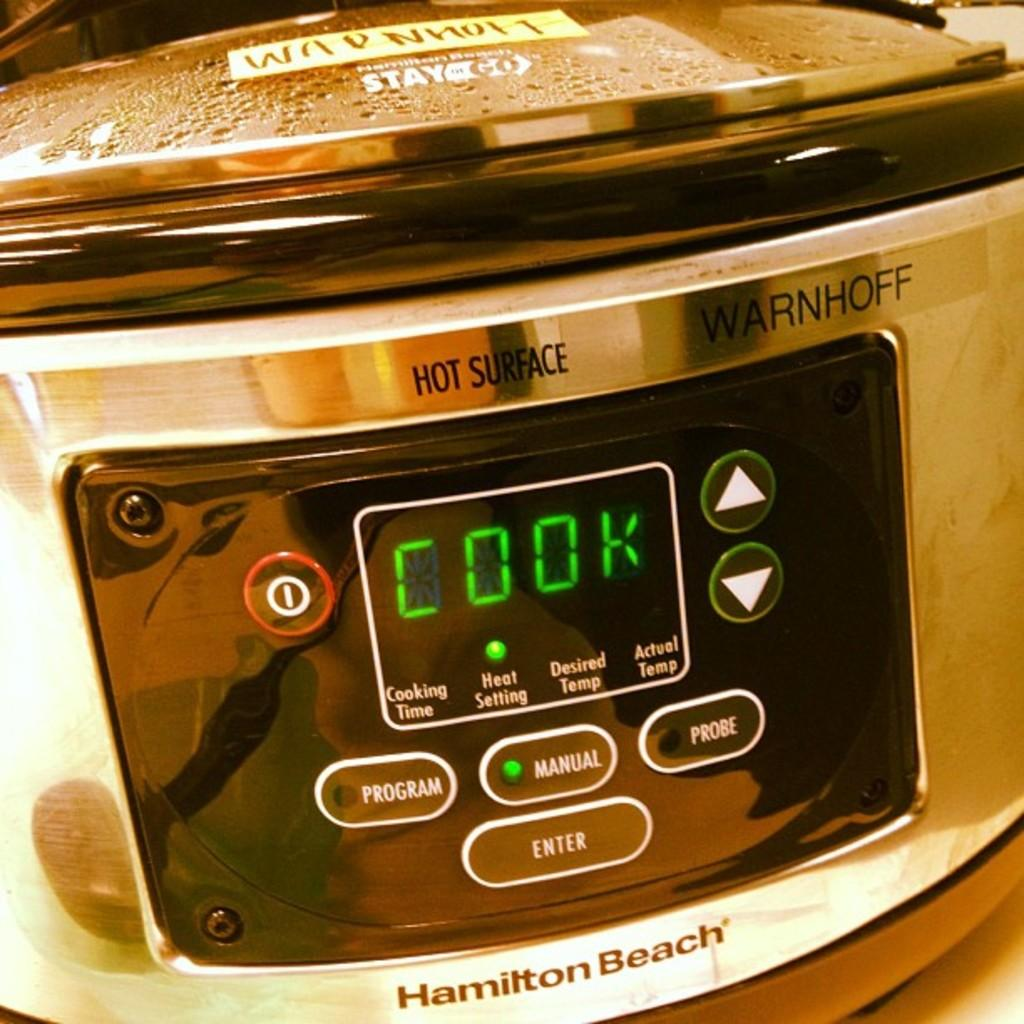<image>
Render a clear and concise summary of the photo. A Hamilton Beach cooker is set to manual. 